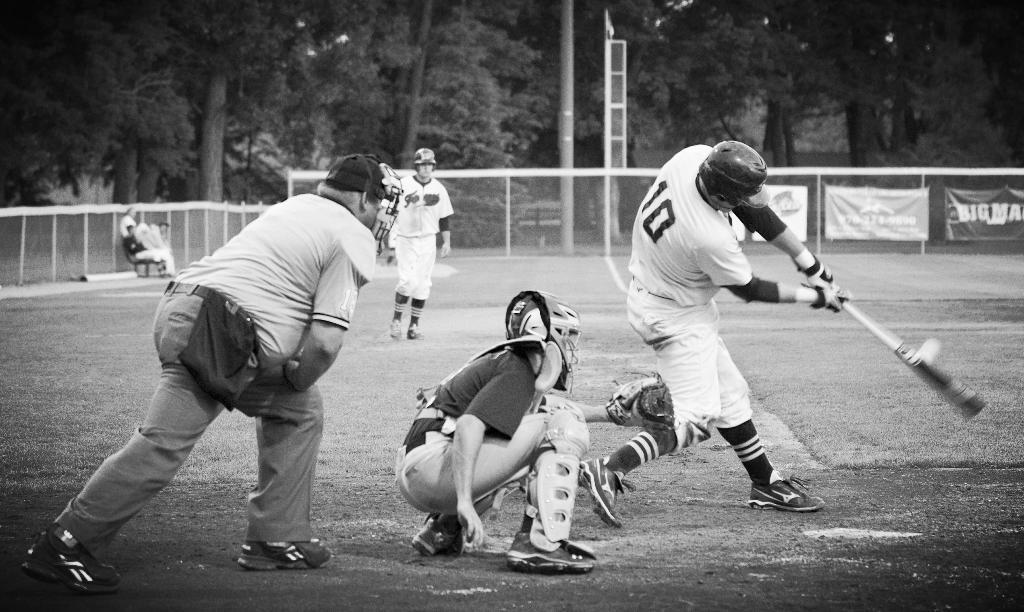Can you describe this image briefly? In the image I can see a group of people playing cricket in the ground, behind him there is a fence and trees. 